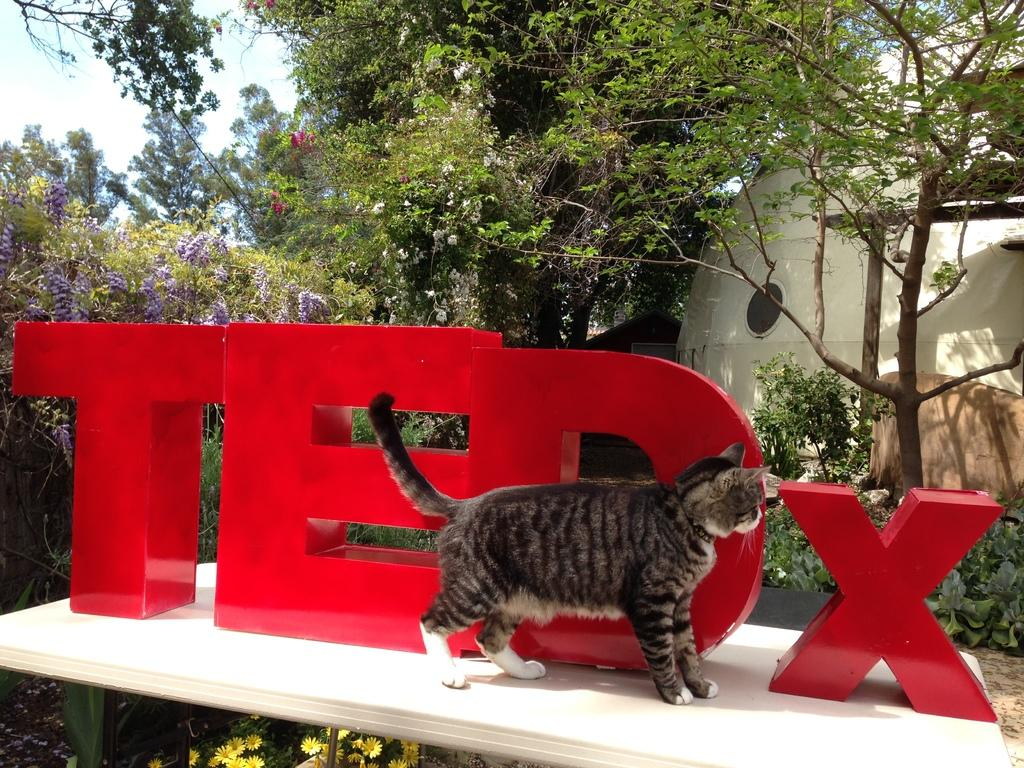What type of animal is in the image? There is a cat in the image. What other living organisms can be seen in the image? There are flowers in the image. What can be seen in the background of the image? There are trees and the sky visible in the background of the image. What type of apple can be seen hanging from the tree in the image? There is no apple present in the image; it features a cat and flowers, with trees visible in the background. What type of cloth is draped over the cat in the image? There is no cloth present in the image; the cat is not wearing or interacting with any cloth. 